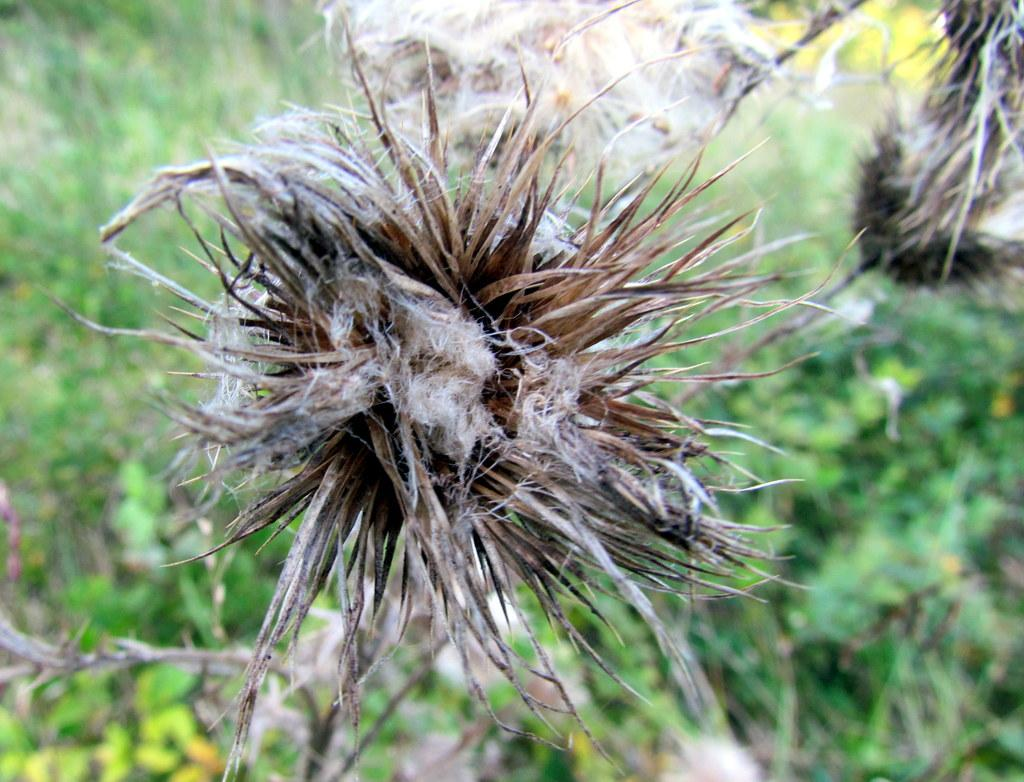What is the main subject of the picture? There is a flower plant in the picture. Can you describe the background of the image? The background of the image is blurred. What else can be seen in the blurred background? There are additional plants visible in the blurred background. What type of tub is visible in the image? There is no tub present in the image. What action is required to start the flower plant growing? The image does not show the flower plant growing or any action required to start its growth. 